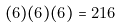Convert formula to latex. <formula><loc_0><loc_0><loc_500><loc_500>( 6 ) ( 6 ) ( 6 ) = 2 1 6</formula> 